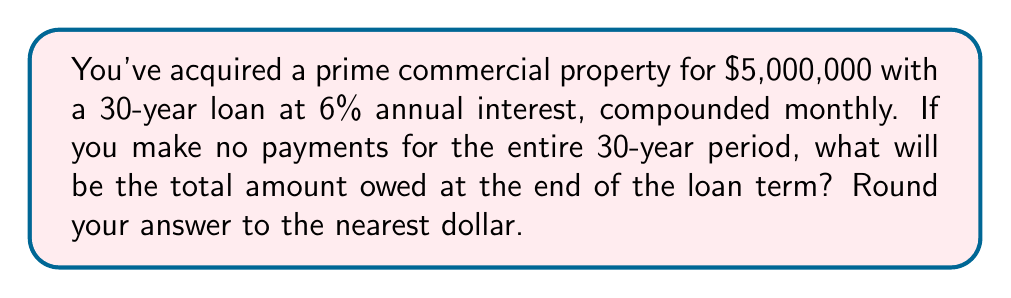Teach me how to tackle this problem. To solve this problem, we'll use the compound interest formula:

$$A = P(1 + \frac{r}{n})^{nt}$$

Where:
$A$ = Final amount
$P$ = Principal (initial investment)
$r$ = Annual interest rate (as a decimal)
$n$ = Number of times interest is compounded per year
$t$ = Number of years

Given:
$P = \$5,000,000$
$r = 0.06$ (6% expressed as a decimal)
$n = 12$ (compounded monthly)
$t = 30$ years

Let's substitute these values into the formula:

$$A = 5,000,000(1 + \frac{0.06}{12})^{12 \cdot 30}$$

$$A = 5,000,000(1 + 0.005)^{360}$$

$$A = 5,000,000(1.005)^{360}$$

Using a calculator or computer to evaluate this expression:

$$A = 5,000,000 \cdot 6.022575$$

$$A = 30,112,875.00$$

Rounding to the nearest dollar:

$$A = \$30,112,875$$
Answer: $30,112,875 